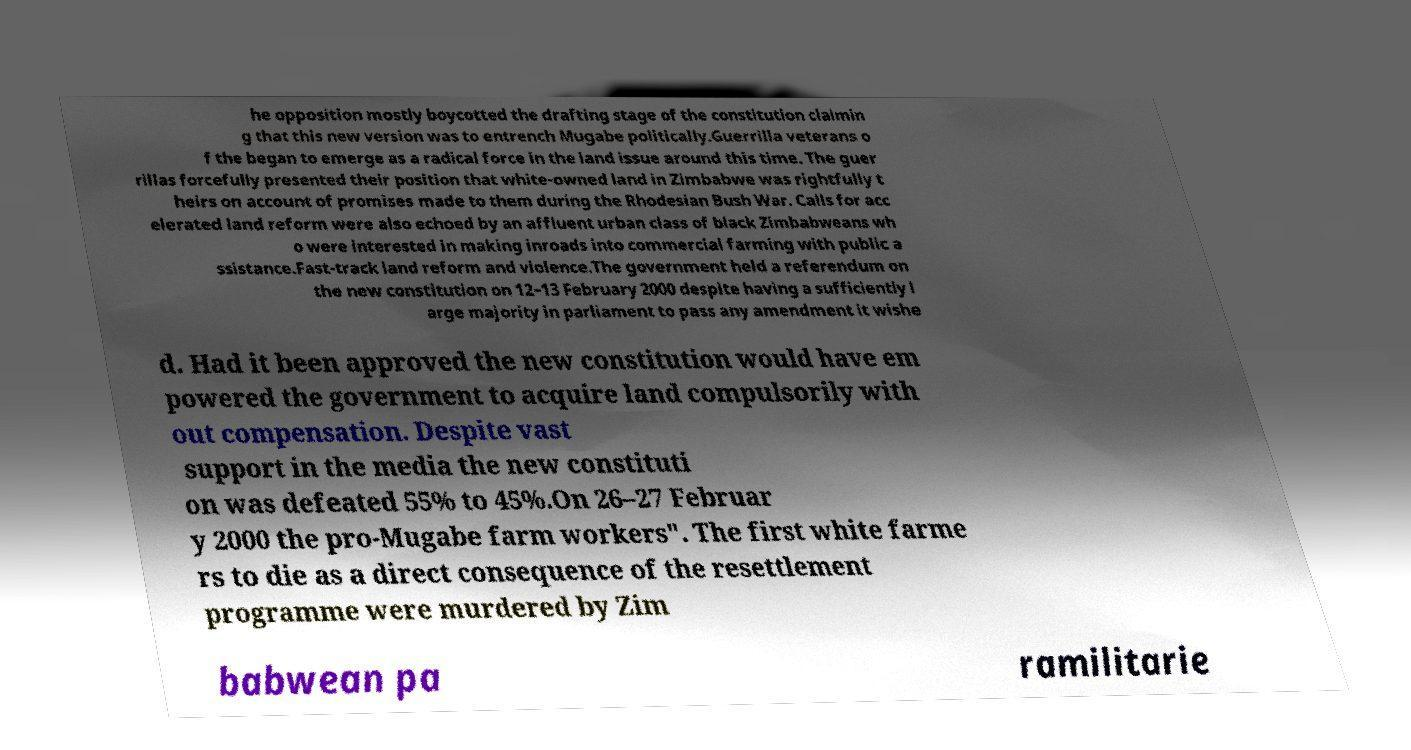Could you assist in decoding the text presented in this image and type it out clearly? he opposition mostly boycotted the drafting stage of the constitution claimin g that this new version was to entrench Mugabe politically.Guerrilla veterans o f the began to emerge as a radical force in the land issue around this time. The guer rillas forcefully presented their position that white-owned land in Zimbabwe was rightfully t heirs on account of promises made to them during the Rhodesian Bush War. Calls for acc elerated land reform were also echoed by an affluent urban class of black Zimbabweans wh o were interested in making inroads into commercial farming with public a ssistance.Fast-track land reform and violence.The government held a referendum on the new constitution on 12–13 February 2000 despite having a sufficiently l arge majority in parliament to pass any amendment it wishe d. Had it been approved the new constitution would have em powered the government to acquire land compulsorily with out compensation. Despite vast support in the media the new constituti on was defeated 55% to 45%.On 26–27 Februar y 2000 the pro-Mugabe farm workers". The first white farme rs to die as a direct consequence of the resettlement programme were murdered by Zim babwean pa ramilitarie 